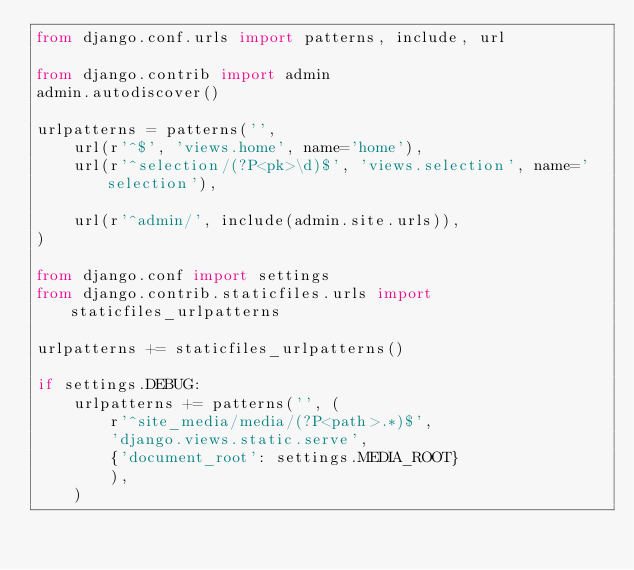<code> <loc_0><loc_0><loc_500><loc_500><_Python_>from django.conf.urls import patterns, include, url

from django.contrib import admin
admin.autodiscover()

urlpatterns = patterns('',
    url(r'^$', 'views.home', name='home'),
    url(r'^selection/(?P<pk>\d)$', 'views.selection', name='selection'),

    url(r'^admin/', include(admin.site.urls)),
)

from django.conf import settings
from django.contrib.staticfiles.urls import staticfiles_urlpatterns

urlpatterns += staticfiles_urlpatterns()

if settings.DEBUG:
    urlpatterns += patterns('', (
        r'^site_media/media/(?P<path>.*)$',
        'django.views.static.serve',
        {'document_root': settings.MEDIA_ROOT}
        ),
    )
</code> 